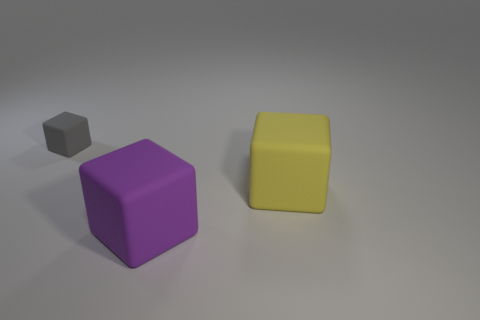Is there a purple matte block right of the large object that is behind the large purple object?
Give a very brief answer. No. Are there any small gray blocks on the left side of the small gray thing?
Keep it short and to the point. No. Do the tiny gray object that is behind the yellow cube and the big yellow thing have the same shape?
Keep it short and to the point. Yes. How many other matte things have the same shape as the tiny object?
Ensure brevity in your answer.  2. Are there any large blue cylinders made of the same material as the purple cube?
Make the answer very short. No. There is a object in front of the big rubber cube behind the large purple block; what is its material?
Ensure brevity in your answer.  Rubber. What is the size of the thing that is on the right side of the purple object?
Give a very brief answer. Large. Does the tiny cube have the same color as the big matte block that is behind the purple rubber object?
Make the answer very short. No. Is there a small rubber cube that has the same color as the small object?
Your response must be concise. No. Is the material of the gray block the same as the yellow block behind the purple object?
Your response must be concise. Yes. 